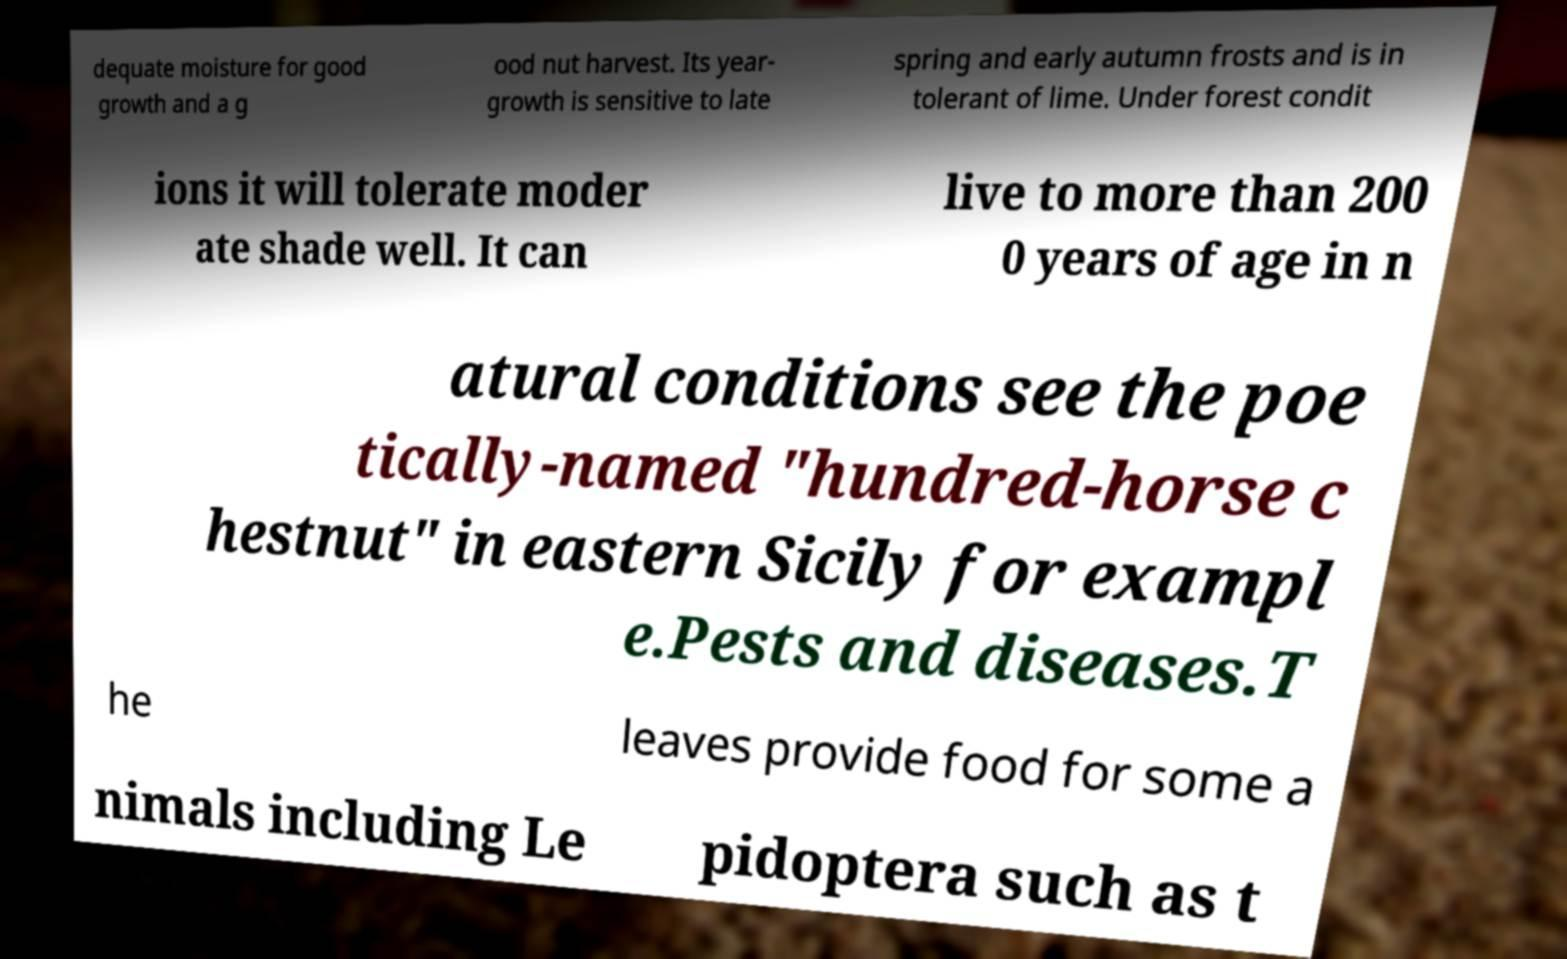Please identify and transcribe the text found in this image. dequate moisture for good growth and a g ood nut harvest. Its year- growth is sensitive to late spring and early autumn frosts and is in tolerant of lime. Under forest condit ions it will tolerate moder ate shade well. It can live to more than 200 0 years of age in n atural conditions see the poe tically-named "hundred-horse c hestnut" in eastern Sicily for exampl e.Pests and diseases.T he leaves provide food for some a nimals including Le pidoptera such as t 